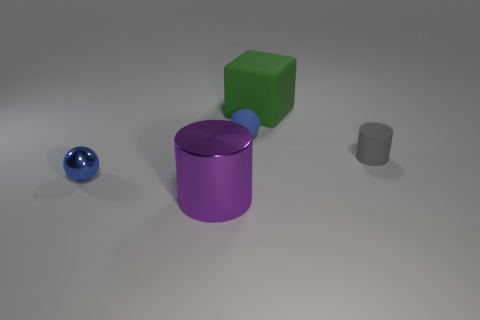Is the number of matte cubes that are on the right side of the green object less than the number of tiny spheres that are on the right side of the small metallic object?
Offer a terse response. Yes. There is a small cylinder that is made of the same material as the block; what is its color?
Provide a short and direct response. Gray. Are there any blue things left of the sphere behind the gray cylinder?
Make the answer very short. Yes. The rubber thing that is the same size as the rubber ball is what color?
Keep it short and to the point. Gray. What number of objects are either large cubes or blue rubber balls?
Make the answer very short. 2. There is a shiny thing in front of the tiny blue ball in front of the tiny object right of the rubber cube; what is its size?
Provide a succinct answer. Large. How many rubber blocks are the same color as the rubber ball?
Ensure brevity in your answer.  0. What number of large purple things are made of the same material as the green block?
Ensure brevity in your answer.  0. How many objects are blocks or big green things right of the large metal object?
Offer a terse response. 1. What color is the sphere left of the blue sphere that is behind the matte object on the right side of the green matte cube?
Make the answer very short. Blue. 